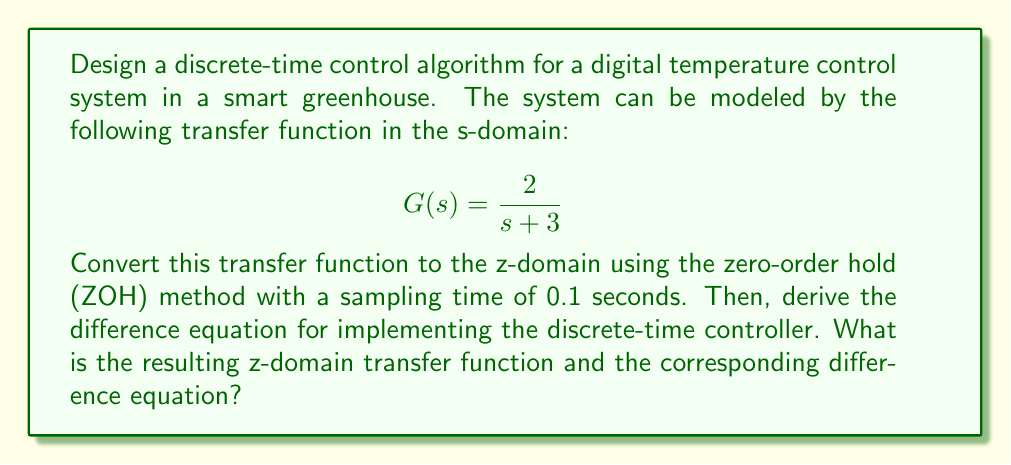Teach me how to tackle this problem. To solve this problem, we'll follow these steps:

1. Convert the continuous-time transfer function to discrete-time using the ZOH method.
2. Derive the z-domain transfer function.
3. Obtain the difference equation from the z-domain transfer function.

Step 1: Converting to discrete-time using ZOH method

The ZOH method for converting from s-domain to z-domain is given by:

$$G(z) = (1-z^{-1})\mathcal{Z}\left\{\frac{G(s)}{s}\right\}$$

Where $\mathcal{Z}\{\}$ denotes the Z-transform.

For our transfer function $G(s) = \frac{2}{s + 3}$, we first need to find $\frac{G(s)}{s}$:

$$\frac{G(s)}{s} = \frac{2}{s(s + 3)}$$

Now, we can apply the Z-transform:

$$\mathcal{Z}\left\{\frac{2}{s(s + 3)}\right\} = \frac{2}{3}\left(\frac{z}{z - 1} - \frac{z}{z - e^{-3T}}\right)$$

Where $T$ is the sampling time (0.1 seconds in this case).

Step 2: Deriving the z-domain transfer function

Substituting $T = 0.1$ and simplifying:

$$G(z) = (1-z^{-1}) \cdot \frac{2}{3}\left(\frac{z}{z - 1} - \frac{z}{z - e^{-0.3}}\right)$$

$$G(z) = \frac{2}{3}\left(1 - \frac{1 - e^{-0.3}}{z - e^{-0.3}}\right)$$

$$G(z) = \frac{2}{3}\left(\frac{z - 1}{z - e^{-0.3}}\right)$$

Simplifying further:

$$G(z) = \frac{0.6667(z - 1)}{z - 0.7408}$$

Step 3: Obtaining the difference equation

To get the difference equation, we can rearrange the z-domain transfer function:

$$Y(z)(z - 0.7408) = 0.6667(z - 1)X(z)$$

$$Y(z)z - 0.7408Y(z) = 0.6667zX(z) - 0.6667X(z)$$

Taking the inverse Z-transform and shifting the indices:

$$y[n+1] - 0.7408y[n] = 0.6667x[n+1] - 0.6667x[n]$$

Rearranging to get the final difference equation:

$$y[n+1] = 0.7408y[n] + 0.6667x[n+1] - 0.6667x[n]$$
Answer: The resulting z-domain transfer function is:

$$G(z) = \frac{0.6667(z - 1)}{z - 0.7408}$$

The corresponding difference equation for implementing the discrete-time controller is:

$$y[n+1] = 0.7408y[n] + 0.6667x[n+1] - 0.6667x[n]$$ 